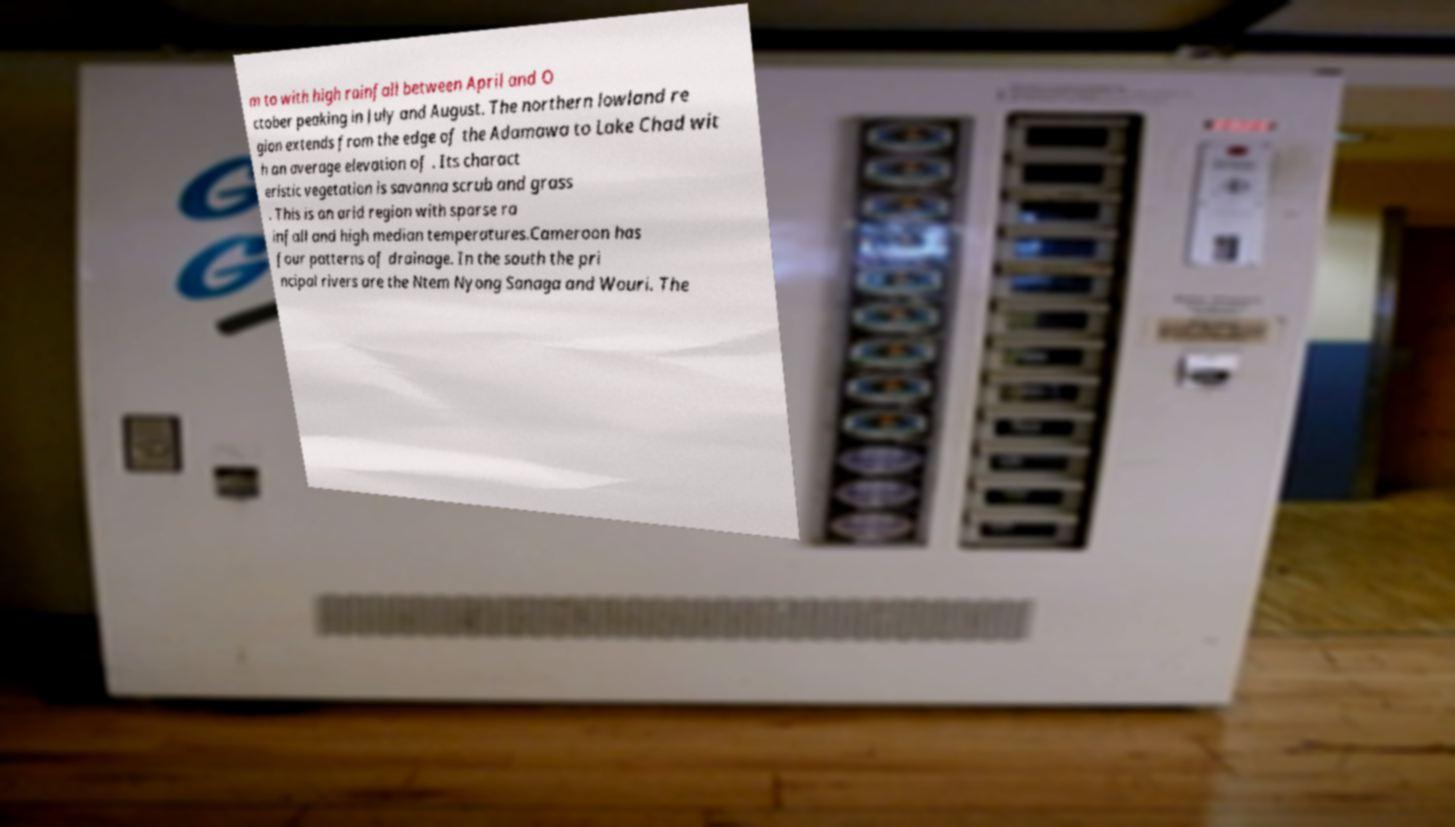Could you assist in decoding the text presented in this image and type it out clearly? m to with high rainfall between April and O ctober peaking in July and August. The northern lowland re gion extends from the edge of the Adamawa to Lake Chad wit h an average elevation of . Its charact eristic vegetation is savanna scrub and grass . This is an arid region with sparse ra infall and high median temperatures.Cameroon has four patterns of drainage. In the south the pri ncipal rivers are the Ntem Nyong Sanaga and Wouri. The 